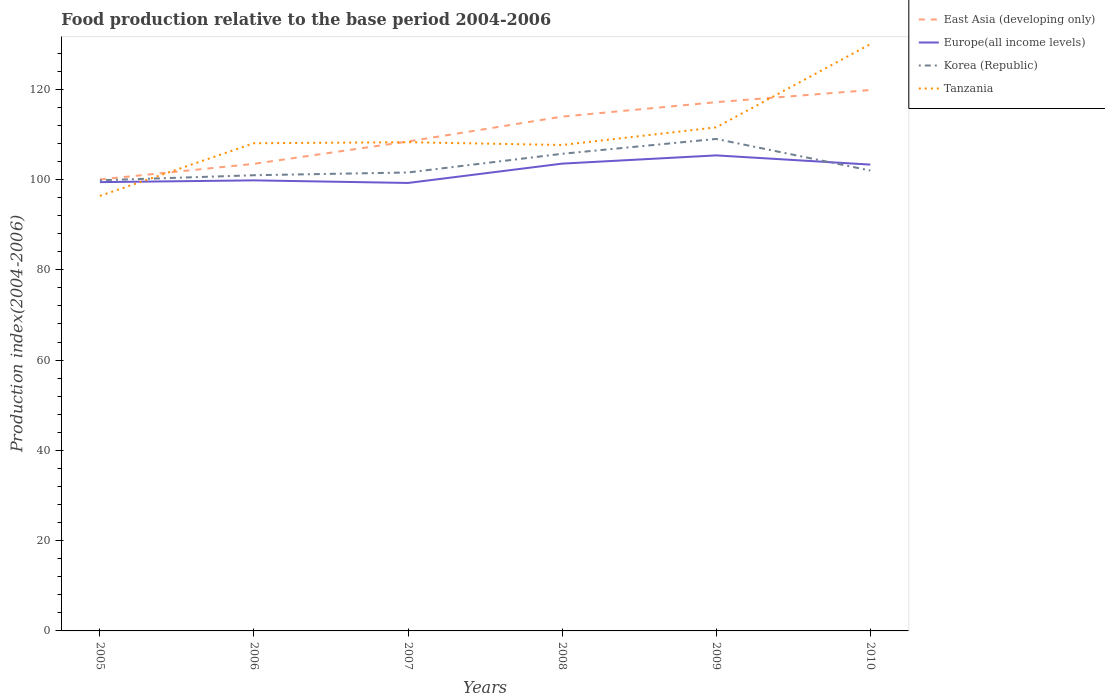Is the number of lines equal to the number of legend labels?
Offer a very short reply. Yes. Across all years, what is the maximum food production index in Tanzania?
Ensure brevity in your answer.  96.39. What is the total food production index in East Asia (developing only) in the graph?
Ensure brevity in your answer.  -19.81. What is the difference between the highest and the second highest food production index in East Asia (developing only)?
Your response must be concise. 19.81. How many lines are there?
Give a very brief answer. 4. How many years are there in the graph?
Your response must be concise. 6. What is the difference between two consecutive major ticks on the Y-axis?
Your answer should be very brief. 20. Does the graph contain grids?
Make the answer very short. No. How many legend labels are there?
Offer a terse response. 4. How are the legend labels stacked?
Your response must be concise. Vertical. What is the title of the graph?
Ensure brevity in your answer.  Food production relative to the base period 2004-2006. What is the label or title of the X-axis?
Your response must be concise. Years. What is the label or title of the Y-axis?
Your response must be concise. Production index(2004-2006). What is the Production index(2004-2006) in East Asia (developing only) in 2005?
Offer a very short reply. 100.03. What is the Production index(2004-2006) of Europe(all income levels) in 2005?
Your answer should be compact. 99.43. What is the Production index(2004-2006) in Korea (Republic) in 2005?
Your response must be concise. 99.84. What is the Production index(2004-2006) in Tanzania in 2005?
Keep it short and to the point. 96.39. What is the Production index(2004-2006) in East Asia (developing only) in 2006?
Ensure brevity in your answer.  103.49. What is the Production index(2004-2006) in Europe(all income levels) in 2006?
Your answer should be very brief. 99.82. What is the Production index(2004-2006) in Korea (Republic) in 2006?
Your response must be concise. 100.96. What is the Production index(2004-2006) of Tanzania in 2006?
Ensure brevity in your answer.  108.05. What is the Production index(2004-2006) of East Asia (developing only) in 2007?
Keep it short and to the point. 108.44. What is the Production index(2004-2006) in Europe(all income levels) in 2007?
Make the answer very short. 99.25. What is the Production index(2004-2006) in Korea (Republic) in 2007?
Keep it short and to the point. 101.57. What is the Production index(2004-2006) in Tanzania in 2007?
Ensure brevity in your answer.  108.28. What is the Production index(2004-2006) of East Asia (developing only) in 2008?
Your answer should be very brief. 113.95. What is the Production index(2004-2006) in Europe(all income levels) in 2008?
Your answer should be very brief. 103.53. What is the Production index(2004-2006) in Korea (Republic) in 2008?
Offer a very short reply. 105.71. What is the Production index(2004-2006) in Tanzania in 2008?
Your answer should be compact. 107.66. What is the Production index(2004-2006) in East Asia (developing only) in 2009?
Offer a very short reply. 117.15. What is the Production index(2004-2006) of Europe(all income levels) in 2009?
Offer a terse response. 105.36. What is the Production index(2004-2006) in Korea (Republic) in 2009?
Your response must be concise. 109. What is the Production index(2004-2006) of Tanzania in 2009?
Provide a short and direct response. 111.57. What is the Production index(2004-2006) of East Asia (developing only) in 2010?
Provide a succinct answer. 119.84. What is the Production index(2004-2006) in Europe(all income levels) in 2010?
Provide a succinct answer. 103.31. What is the Production index(2004-2006) in Korea (Republic) in 2010?
Ensure brevity in your answer.  102. What is the Production index(2004-2006) in Tanzania in 2010?
Keep it short and to the point. 130. Across all years, what is the maximum Production index(2004-2006) of East Asia (developing only)?
Offer a very short reply. 119.84. Across all years, what is the maximum Production index(2004-2006) in Europe(all income levels)?
Provide a succinct answer. 105.36. Across all years, what is the maximum Production index(2004-2006) in Korea (Republic)?
Ensure brevity in your answer.  109. Across all years, what is the maximum Production index(2004-2006) in Tanzania?
Provide a short and direct response. 130. Across all years, what is the minimum Production index(2004-2006) of East Asia (developing only)?
Provide a short and direct response. 100.03. Across all years, what is the minimum Production index(2004-2006) in Europe(all income levels)?
Your response must be concise. 99.25. Across all years, what is the minimum Production index(2004-2006) of Korea (Republic)?
Provide a short and direct response. 99.84. Across all years, what is the minimum Production index(2004-2006) of Tanzania?
Your response must be concise. 96.39. What is the total Production index(2004-2006) in East Asia (developing only) in the graph?
Give a very brief answer. 662.88. What is the total Production index(2004-2006) in Europe(all income levels) in the graph?
Your answer should be very brief. 610.71. What is the total Production index(2004-2006) of Korea (Republic) in the graph?
Offer a very short reply. 619.08. What is the total Production index(2004-2006) in Tanzania in the graph?
Offer a terse response. 661.95. What is the difference between the Production index(2004-2006) in East Asia (developing only) in 2005 and that in 2006?
Provide a succinct answer. -3.46. What is the difference between the Production index(2004-2006) in Europe(all income levels) in 2005 and that in 2006?
Offer a terse response. -0.39. What is the difference between the Production index(2004-2006) of Korea (Republic) in 2005 and that in 2006?
Provide a short and direct response. -1.12. What is the difference between the Production index(2004-2006) of Tanzania in 2005 and that in 2006?
Provide a short and direct response. -11.66. What is the difference between the Production index(2004-2006) in East Asia (developing only) in 2005 and that in 2007?
Ensure brevity in your answer.  -8.41. What is the difference between the Production index(2004-2006) of Europe(all income levels) in 2005 and that in 2007?
Provide a short and direct response. 0.19. What is the difference between the Production index(2004-2006) in Korea (Republic) in 2005 and that in 2007?
Provide a short and direct response. -1.73. What is the difference between the Production index(2004-2006) in Tanzania in 2005 and that in 2007?
Offer a terse response. -11.89. What is the difference between the Production index(2004-2006) in East Asia (developing only) in 2005 and that in 2008?
Provide a short and direct response. -13.92. What is the difference between the Production index(2004-2006) in Europe(all income levels) in 2005 and that in 2008?
Offer a very short reply. -4.1. What is the difference between the Production index(2004-2006) of Korea (Republic) in 2005 and that in 2008?
Offer a terse response. -5.87. What is the difference between the Production index(2004-2006) in Tanzania in 2005 and that in 2008?
Your answer should be very brief. -11.27. What is the difference between the Production index(2004-2006) in East Asia (developing only) in 2005 and that in 2009?
Ensure brevity in your answer.  -17.12. What is the difference between the Production index(2004-2006) in Europe(all income levels) in 2005 and that in 2009?
Your answer should be very brief. -5.92. What is the difference between the Production index(2004-2006) in Korea (Republic) in 2005 and that in 2009?
Offer a terse response. -9.16. What is the difference between the Production index(2004-2006) of Tanzania in 2005 and that in 2009?
Offer a very short reply. -15.18. What is the difference between the Production index(2004-2006) of East Asia (developing only) in 2005 and that in 2010?
Keep it short and to the point. -19.81. What is the difference between the Production index(2004-2006) of Europe(all income levels) in 2005 and that in 2010?
Give a very brief answer. -3.88. What is the difference between the Production index(2004-2006) in Korea (Republic) in 2005 and that in 2010?
Offer a very short reply. -2.16. What is the difference between the Production index(2004-2006) of Tanzania in 2005 and that in 2010?
Provide a succinct answer. -33.61. What is the difference between the Production index(2004-2006) in East Asia (developing only) in 2006 and that in 2007?
Give a very brief answer. -4.95. What is the difference between the Production index(2004-2006) in Europe(all income levels) in 2006 and that in 2007?
Make the answer very short. 0.57. What is the difference between the Production index(2004-2006) of Korea (Republic) in 2006 and that in 2007?
Keep it short and to the point. -0.61. What is the difference between the Production index(2004-2006) in Tanzania in 2006 and that in 2007?
Give a very brief answer. -0.23. What is the difference between the Production index(2004-2006) of East Asia (developing only) in 2006 and that in 2008?
Your answer should be compact. -10.46. What is the difference between the Production index(2004-2006) of Europe(all income levels) in 2006 and that in 2008?
Provide a short and direct response. -3.71. What is the difference between the Production index(2004-2006) of Korea (Republic) in 2006 and that in 2008?
Your answer should be compact. -4.75. What is the difference between the Production index(2004-2006) of Tanzania in 2006 and that in 2008?
Give a very brief answer. 0.39. What is the difference between the Production index(2004-2006) of East Asia (developing only) in 2006 and that in 2009?
Your answer should be compact. -13.66. What is the difference between the Production index(2004-2006) in Europe(all income levels) in 2006 and that in 2009?
Offer a very short reply. -5.53. What is the difference between the Production index(2004-2006) in Korea (Republic) in 2006 and that in 2009?
Ensure brevity in your answer.  -8.04. What is the difference between the Production index(2004-2006) of Tanzania in 2006 and that in 2009?
Your response must be concise. -3.52. What is the difference between the Production index(2004-2006) of East Asia (developing only) in 2006 and that in 2010?
Your response must be concise. -16.35. What is the difference between the Production index(2004-2006) in Europe(all income levels) in 2006 and that in 2010?
Your answer should be compact. -3.49. What is the difference between the Production index(2004-2006) of Korea (Republic) in 2006 and that in 2010?
Provide a short and direct response. -1.04. What is the difference between the Production index(2004-2006) of Tanzania in 2006 and that in 2010?
Offer a terse response. -21.95. What is the difference between the Production index(2004-2006) of East Asia (developing only) in 2007 and that in 2008?
Your response must be concise. -5.51. What is the difference between the Production index(2004-2006) of Europe(all income levels) in 2007 and that in 2008?
Provide a short and direct response. -4.28. What is the difference between the Production index(2004-2006) of Korea (Republic) in 2007 and that in 2008?
Offer a very short reply. -4.14. What is the difference between the Production index(2004-2006) in Tanzania in 2007 and that in 2008?
Offer a terse response. 0.62. What is the difference between the Production index(2004-2006) of East Asia (developing only) in 2007 and that in 2009?
Provide a succinct answer. -8.71. What is the difference between the Production index(2004-2006) in Europe(all income levels) in 2007 and that in 2009?
Offer a terse response. -6.11. What is the difference between the Production index(2004-2006) in Korea (Republic) in 2007 and that in 2009?
Your response must be concise. -7.43. What is the difference between the Production index(2004-2006) in Tanzania in 2007 and that in 2009?
Make the answer very short. -3.29. What is the difference between the Production index(2004-2006) of East Asia (developing only) in 2007 and that in 2010?
Provide a succinct answer. -11.4. What is the difference between the Production index(2004-2006) in Europe(all income levels) in 2007 and that in 2010?
Provide a short and direct response. -4.06. What is the difference between the Production index(2004-2006) in Korea (Republic) in 2007 and that in 2010?
Provide a succinct answer. -0.43. What is the difference between the Production index(2004-2006) in Tanzania in 2007 and that in 2010?
Your answer should be compact. -21.72. What is the difference between the Production index(2004-2006) of East Asia (developing only) in 2008 and that in 2009?
Your answer should be compact. -3.2. What is the difference between the Production index(2004-2006) of Europe(all income levels) in 2008 and that in 2009?
Provide a succinct answer. -1.82. What is the difference between the Production index(2004-2006) in Korea (Republic) in 2008 and that in 2009?
Your answer should be compact. -3.29. What is the difference between the Production index(2004-2006) of Tanzania in 2008 and that in 2009?
Your answer should be very brief. -3.91. What is the difference between the Production index(2004-2006) of East Asia (developing only) in 2008 and that in 2010?
Your response must be concise. -5.89. What is the difference between the Production index(2004-2006) of Europe(all income levels) in 2008 and that in 2010?
Provide a short and direct response. 0.22. What is the difference between the Production index(2004-2006) of Korea (Republic) in 2008 and that in 2010?
Your answer should be very brief. 3.71. What is the difference between the Production index(2004-2006) in Tanzania in 2008 and that in 2010?
Give a very brief answer. -22.34. What is the difference between the Production index(2004-2006) in East Asia (developing only) in 2009 and that in 2010?
Your answer should be very brief. -2.69. What is the difference between the Production index(2004-2006) in Europe(all income levels) in 2009 and that in 2010?
Offer a very short reply. 2.04. What is the difference between the Production index(2004-2006) of Tanzania in 2009 and that in 2010?
Give a very brief answer. -18.43. What is the difference between the Production index(2004-2006) of East Asia (developing only) in 2005 and the Production index(2004-2006) of Europe(all income levels) in 2006?
Offer a terse response. 0.2. What is the difference between the Production index(2004-2006) of East Asia (developing only) in 2005 and the Production index(2004-2006) of Korea (Republic) in 2006?
Make the answer very short. -0.93. What is the difference between the Production index(2004-2006) in East Asia (developing only) in 2005 and the Production index(2004-2006) in Tanzania in 2006?
Provide a succinct answer. -8.02. What is the difference between the Production index(2004-2006) of Europe(all income levels) in 2005 and the Production index(2004-2006) of Korea (Republic) in 2006?
Keep it short and to the point. -1.53. What is the difference between the Production index(2004-2006) in Europe(all income levels) in 2005 and the Production index(2004-2006) in Tanzania in 2006?
Make the answer very short. -8.62. What is the difference between the Production index(2004-2006) in Korea (Republic) in 2005 and the Production index(2004-2006) in Tanzania in 2006?
Keep it short and to the point. -8.21. What is the difference between the Production index(2004-2006) in East Asia (developing only) in 2005 and the Production index(2004-2006) in Europe(all income levels) in 2007?
Your response must be concise. 0.78. What is the difference between the Production index(2004-2006) of East Asia (developing only) in 2005 and the Production index(2004-2006) of Korea (Republic) in 2007?
Your answer should be compact. -1.54. What is the difference between the Production index(2004-2006) in East Asia (developing only) in 2005 and the Production index(2004-2006) in Tanzania in 2007?
Provide a succinct answer. -8.25. What is the difference between the Production index(2004-2006) in Europe(all income levels) in 2005 and the Production index(2004-2006) in Korea (Republic) in 2007?
Offer a very short reply. -2.14. What is the difference between the Production index(2004-2006) of Europe(all income levels) in 2005 and the Production index(2004-2006) of Tanzania in 2007?
Ensure brevity in your answer.  -8.85. What is the difference between the Production index(2004-2006) of Korea (Republic) in 2005 and the Production index(2004-2006) of Tanzania in 2007?
Your answer should be very brief. -8.44. What is the difference between the Production index(2004-2006) of East Asia (developing only) in 2005 and the Production index(2004-2006) of Europe(all income levels) in 2008?
Provide a short and direct response. -3.51. What is the difference between the Production index(2004-2006) of East Asia (developing only) in 2005 and the Production index(2004-2006) of Korea (Republic) in 2008?
Your response must be concise. -5.68. What is the difference between the Production index(2004-2006) in East Asia (developing only) in 2005 and the Production index(2004-2006) in Tanzania in 2008?
Your answer should be very brief. -7.63. What is the difference between the Production index(2004-2006) in Europe(all income levels) in 2005 and the Production index(2004-2006) in Korea (Republic) in 2008?
Your answer should be compact. -6.28. What is the difference between the Production index(2004-2006) in Europe(all income levels) in 2005 and the Production index(2004-2006) in Tanzania in 2008?
Provide a succinct answer. -8.23. What is the difference between the Production index(2004-2006) in Korea (Republic) in 2005 and the Production index(2004-2006) in Tanzania in 2008?
Keep it short and to the point. -7.82. What is the difference between the Production index(2004-2006) in East Asia (developing only) in 2005 and the Production index(2004-2006) in Europe(all income levels) in 2009?
Provide a succinct answer. -5.33. What is the difference between the Production index(2004-2006) in East Asia (developing only) in 2005 and the Production index(2004-2006) in Korea (Republic) in 2009?
Offer a very short reply. -8.97. What is the difference between the Production index(2004-2006) of East Asia (developing only) in 2005 and the Production index(2004-2006) of Tanzania in 2009?
Your answer should be compact. -11.54. What is the difference between the Production index(2004-2006) of Europe(all income levels) in 2005 and the Production index(2004-2006) of Korea (Republic) in 2009?
Offer a very short reply. -9.57. What is the difference between the Production index(2004-2006) in Europe(all income levels) in 2005 and the Production index(2004-2006) in Tanzania in 2009?
Your answer should be very brief. -12.14. What is the difference between the Production index(2004-2006) in Korea (Republic) in 2005 and the Production index(2004-2006) in Tanzania in 2009?
Ensure brevity in your answer.  -11.73. What is the difference between the Production index(2004-2006) in East Asia (developing only) in 2005 and the Production index(2004-2006) in Europe(all income levels) in 2010?
Keep it short and to the point. -3.29. What is the difference between the Production index(2004-2006) in East Asia (developing only) in 2005 and the Production index(2004-2006) in Korea (Republic) in 2010?
Give a very brief answer. -1.97. What is the difference between the Production index(2004-2006) of East Asia (developing only) in 2005 and the Production index(2004-2006) of Tanzania in 2010?
Your response must be concise. -29.97. What is the difference between the Production index(2004-2006) in Europe(all income levels) in 2005 and the Production index(2004-2006) in Korea (Republic) in 2010?
Your answer should be very brief. -2.57. What is the difference between the Production index(2004-2006) of Europe(all income levels) in 2005 and the Production index(2004-2006) of Tanzania in 2010?
Offer a very short reply. -30.57. What is the difference between the Production index(2004-2006) of Korea (Republic) in 2005 and the Production index(2004-2006) of Tanzania in 2010?
Offer a very short reply. -30.16. What is the difference between the Production index(2004-2006) of East Asia (developing only) in 2006 and the Production index(2004-2006) of Europe(all income levels) in 2007?
Keep it short and to the point. 4.24. What is the difference between the Production index(2004-2006) in East Asia (developing only) in 2006 and the Production index(2004-2006) in Korea (Republic) in 2007?
Your response must be concise. 1.92. What is the difference between the Production index(2004-2006) of East Asia (developing only) in 2006 and the Production index(2004-2006) of Tanzania in 2007?
Your answer should be compact. -4.79. What is the difference between the Production index(2004-2006) in Europe(all income levels) in 2006 and the Production index(2004-2006) in Korea (Republic) in 2007?
Your answer should be very brief. -1.75. What is the difference between the Production index(2004-2006) of Europe(all income levels) in 2006 and the Production index(2004-2006) of Tanzania in 2007?
Give a very brief answer. -8.46. What is the difference between the Production index(2004-2006) of Korea (Republic) in 2006 and the Production index(2004-2006) of Tanzania in 2007?
Keep it short and to the point. -7.32. What is the difference between the Production index(2004-2006) in East Asia (developing only) in 2006 and the Production index(2004-2006) in Europe(all income levels) in 2008?
Give a very brief answer. -0.05. What is the difference between the Production index(2004-2006) of East Asia (developing only) in 2006 and the Production index(2004-2006) of Korea (Republic) in 2008?
Provide a short and direct response. -2.22. What is the difference between the Production index(2004-2006) of East Asia (developing only) in 2006 and the Production index(2004-2006) of Tanzania in 2008?
Provide a short and direct response. -4.17. What is the difference between the Production index(2004-2006) of Europe(all income levels) in 2006 and the Production index(2004-2006) of Korea (Republic) in 2008?
Offer a very short reply. -5.89. What is the difference between the Production index(2004-2006) in Europe(all income levels) in 2006 and the Production index(2004-2006) in Tanzania in 2008?
Provide a short and direct response. -7.84. What is the difference between the Production index(2004-2006) of Korea (Republic) in 2006 and the Production index(2004-2006) of Tanzania in 2008?
Your answer should be very brief. -6.7. What is the difference between the Production index(2004-2006) in East Asia (developing only) in 2006 and the Production index(2004-2006) in Europe(all income levels) in 2009?
Your response must be concise. -1.87. What is the difference between the Production index(2004-2006) of East Asia (developing only) in 2006 and the Production index(2004-2006) of Korea (Republic) in 2009?
Ensure brevity in your answer.  -5.51. What is the difference between the Production index(2004-2006) in East Asia (developing only) in 2006 and the Production index(2004-2006) in Tanzania in 2009?
Provide a short and direct response. -8.08. What is the difference between the Production index(2004-2006) of Europe(all income levels) in 2006 and the Production index(2004-2006) of Korea (Republic) in 2009?
Make the answer very short. -9.18. What is the difference between the Production index(2004-2006) of Europe(all income levels) in 2006 and the Production index(2004-2006) of Tanzania in 2009?
Offer a very short reply. -11.75. What is the difference between the Production index(2004-2006) in Korea (Republic) in 2006 and the Production index(2004-2006) in Tanzania in 2009?
Provide a succinct answer. -10.61. What is the difference between the Production index(2004-2006) in East Asia (developing only) in 2006 and the Production index(2004-2006) in Europe(all income levels) in 2010?
Ensure brevity in your answer.  0.17. What is the difference between the Production index(2004-2006) in East Asia (developing only) in 2006 and the Production index(2004-2006) in Korea (Republic) in 2010?
Offer a terse response. 1.49. What is the difference between the Production index(2004-2006) of East Asia (developing only) in 2006 and the Production index(2004-2006) of Tanzania in 2010?
Offer a very short reply. -26.51. What is the difference between the Production index(2004-2006) of Europe(all income levels) in 2006 and the Production index(2004-2006) of Korea (Republic) in 2010?
Offer a terse response. -2.18. What is the difference between the Production index(2004-2006) in Europe(all income levels) in 2006 and the Production index(2004-2006) in Tanzania in 2010?
Make the answer very short. -30.18. What is the difference between the Production index(2004-2006) of Korea (Republic) in 2006 and the Production index(2004-2006) of Tanzania in 2010?
Your answer should be compact. -29.04. What is the difference between the Production index(2004-2006) of East Asia (developing only) in 2007 and the Production index(2004-2006) of Europe(all income levels) in 2008?
Make the answer very short. 4.91. What is the difference between the Production index(2004-2006) of East Asia (developing only) in 2007 and the Production index(2004-2006) of Korea (Republic) in 2008?
Offer a terse response. 2.73. What is the difference between the Production index(2004-2006) in East Asia (developing only) in 2007 and the Production index(2004-2006) in Tanzania in 2008?
Your answer should be compact. 0.78. What is the difference between the Production index(2004-2006) in Europe(all income levels) in 2007 and the Production index(2004-2006) in Korea (Republic) in 2008?
Ensure brevity in your answer.  -6.46. What is the difference between the Production index(2004-2006) in Europe(all income levels) in 2007 and the Production index(2004-2006) in Tanzania in 2008?
Provide a short and direct response. -8.41. What is the difference between the Production index(2004-2006) in Korea (Republic) in 2007 and the Production index(2004-2006) in Tanzania in 2008?
Your answer should be compact. -6.09. What is the difference between the Production index(2004-2006) of East Asia (developing only) in 2007 and the Production index(2004-2006) of Europe(all income levels) in 2009?
Make the answer very short. 3.08. What is the difference between the Production index(2004-2006) of East Asia (developing only) in 2007 and the Production index(2004-2006) of Korea (Republic) in 2009?
Keep it short and to the point. -0.56. What is the difference between the Production index(2004-2006) in East Asia (developing only) in 2007 and the Production index(2004-2006) in Tanzania in 2009?
Keep it short and to the point. -3.13. What is the difference between the Production index(2004-2006) of Europe(all income levels) in 2007 and the Production index(2004-2006) of Korea (Republic) in 2009?
Your response must be concise. -9.75. What is the difference between the Production index(2004-2006) in Europe(all income levels) in 2007 and the Production index(2004-2006) in Tanzania in 2009?
Your answer should be very brief. -12.32. What is the difference between the Production index(2004-2006) of Korea (Republic) in 2007 and the Production index(2004-2006) of Tanzania in 2009?
Your answer should be compact. -10. What is the difference between the Production index(2004-2006) of East Asia (developing only) in 2007 and the Production index(2004-2006) of Europe(all income levels) in 2010?
Make the answer very short. 5.13. What is the difference between the Production index(2004-2006) of East Asia (developing only) in 2007 and the Production index(2004-2006) of Korea (Republic) in 2010?
Keep it short and to the point. 6.44. What is the difference between the Production index(2004-2006) of East Asia (developing only) in 2007 and the Production index(2004-2006) of Tanzania in 2010?
Make the answer very short. -21.56. What is the difference between the Production index(2004-2006) of Europe(all income levels) in 2007 and the Production index(2004-2006) of Korea (Republic) in 2010?
Keep it short and to the point. -2.75. What is the difference between the Production index(2004-2006) of Europe(all income levels) in 2007 and the Production index(2004-2006) of Tanzania in 2010?
Offer a very short reply. -30.75. What is the difference between the Production index(2004-2006) of Korea (Republic) in 2007 and the Production index(2004-2006) of Tanzania in 2010?
Provide a succinct answer. -28.43. What is the difference between the Production index(2004-2006) of East Asia (developing only) in 2008 and the Production index(2004-2006) of Europe(all income levels) in 2009?
Make the answer very short. 8.59. What is the difference between the Production index(2004-2006) in East Asia (developing only) in 2008 and the Production index(2004-2006) in Korea (Republic) in 2009?
Make the answer very short. 4.95. What is the difference between the Production index(2004-2006) of East Asia (developing only) in 2008 and the Production index(2004-2006) of Tanzania in 2009?
Provide a short and direct response. 2.38. What is the difference between the Production index(2004-2006) of Europe(all income levels) in 2008 and the Production index(2004-2006) of Korea (Republic) in 2009?
Your response must be concise. -5.47. What is the difference between the Production index(2004-2006) of Europe(all income levels) in 2008 and the Production index(2004-2006) of Tanzania in 2009?
Make the answer very short. -8.04. What is the difference between the Production index(2004-2006) of Korea (Republic) in 2008 and the Production index(2004-2006) of Tanzania in 2009?
Ensure brevity in your answer.  -5.86. What is the difference between the Production index(2004-2006) of East Asia (developing only) in 2008 and the Production index(2004-2006) of Europe(all income levels) in 2010?
Make the answer very short. 10.63. What is the difference between the Production index(2004-2006) in East Asia (developing only) in 2008 and the Production index(2004-2006) in Korea (Republic) in 2010?
Provide a short and direct response. 11.95. What is the difference between the Production index(2004-2006) of East Asia (developing only) in 2008 and the Production index(2004-2006) of Tanzania in 2010?
Offer a terse response. -16.05. What is the difference between the Production index(2004-2006) of Europe(all income levels) in 2008 and the Production index(2004-2006) of Korea (Republic) in 2010?
Your response must be concise. 1.53. What is the difference between the Production index(2004-2006) of Europe(all income levels) in 2008 and the Production index(2004-2006) of Tanzania in 2010?
Give a very brief answer. -26.47. What is the difference between the Production index(2004-2006) of Korea (Republic) in 2008 and the Production index(2004-2006) of Tanzania in 2010?
Keep it short and to the point. -24.29. What is the difference between the Production index(2004-2006) in East Asia (developing only) in 2009 and the Production index(2004-2006) in Europe(all income levels) in 2010?
Keep it short and to the point. 13.84. What is the difference between the Production index(2004-2006) of East Asia (developing only) in 2009 and the Production index(2004-2006) of Korea (Republic) in 2010?
Ensure brevity in your answer.  15.15. What is the difference between the Production index(2004-2006) of East Asia (developing only) in 2009 and the Production index(2004-2006) of Tanzania in 2010?
Offer a terse response. -12.85. What is the difference between the Production index(2004-2006) of Europe(all income levels) in 2009 and the Production index(2004-2006) of Korea (Republic) in 2010?
Keep it short and to the point. 3.36. What is the difference between the Production index(2004-2006) of Europe(all income levels) in 2009 and the Production index(2004-2006) of Tanzania in 2010?
Give a very brief answer. -24.64. What is the average Production index(2004-2006) in East Asia (developing only) per year?
Keep it short and to the point. 110.48. What is the average Production index(2004-2006) of Europe(all income levels) per year?
Provide a succinct answer. 101.78. What is the average Production index(2004-2006) in Korea (Republic) per year?
Offer a terse response. 103.18. What is the average Production index(2004-2006) in Tanzania per year?
Offer a very short reply. 110.33. In the year 2005, what is the difference between the Production index(2004-2006) of East Asia (developing only) and Production index(2004-2006) of Europe(all income levels)?
Offer a terse response. 0.59. In the year 2005, what is the difference between the Production index(2004-2006) of East Asia (developing only) and Production index(2004-2006) of Korea (Republic)?
Your answer should be very brief. 0.19. In the year 2005, what is the difference between the Production index(2004-2006) of East Asia (developing only) and Production index(2004-2006) of Tanzania?
Offer a very short reply. 3.64. In the year 2005, what is the difference between the Production index(2004-2006) in Europe(all income levels) and Production index(2004-2006) in Korea (Republic)?
Provide a short and direct response. -0.41. In the year 2005, what is the difference between the Production index(2004-2006) of Europe(all income levels) and Production index(2004-2006) of Tanzania?
Your answer should be very brief. 3.04. In the year 2005, what is the difference between the Production index(2004-2006) of Korea (Republic) and Production index(2004-2006) of Tanzania?
Your answer should be very brief. 3.45. In the year 2006, what is the difference between the Production index(2004-2006) in East Asia (developing only) and Production index(2004-2006) in Europe(all income levels)?
Keep it short and to the point. 3.66. In the year 2006, what is the difference between the Production index(2004-2006) in East Asia (developing only) and Production index(2004-2006) in Korea (Republic)?
Provide a succinct answer. 2.53. In the year 2006, what is the difference between the Production index(2004-2006) in East Asia (developing only) and Production index(2004-2006) in Tanzania?
Provide a short and direct response. -4.56. In the year 2006, what is the difference between the Production index(2004-2006) in Europe(all income levels) and Production index(2004-2006) in Korea (Republic)?
Keep it short and to the point. -1.14. In the year 2006, what is the difference between the Production index(2004-2006) in Europe(all income levels) and Production index(2004-2006) in Tanzania?
Offer a very short reply. -8.23. In the year 2006, what is the difference between the Production index(2004-2006) in Korea (Republic) and Production index(2004-2006) in Tanzania?
Your answer should be compact. -7.09. In the year 2007, what is the difference between the Production index(2004-2006) in East Asia (developing only) and Production index(2004-2006) in Europe(all income levels)?
Ensure brevity in your answer.  9.19. In the year 2007, what is the difference between the Production index(2004-2006) in East Asia (developing only) and Production index(2004-2006) in Korea (Republic)?
Make the answer very short. 6.87. In the year 2007, what is the difference between the Production index(2004-2006) of East Asia (developing only) and Production index(2004-2006) of Tanzania?
Offer a terse response. 0.16. In the year 2007, what is the difference between the Production index(2004-2006) of Europe(all income levels) and Production index(2004-2006) of Korea (Republic)?
Give a very brief answer. -2.32. In the year 2007, what is the difference between the Production index(2004-2006) in Europe(all income levels) and Production index(2004-2006) in Tanzania?
Offer a very short reply. -9.03. In the year 2007, what is the difference between the Production index(2004-2006) in Korea (Republic) and Production index(2004-2006) in Tanzania?
Keep it short and to the point. -6.71. In the year 2008, what is the difference between the Production index(2004-2006) in East Asia (developing only) and Production index(2004-2006) in Europe(all income levels)?
Make the answer very short. 10.42. In the year 2008, what is the difference between the Production index(2004-2006) of East Asia (developing only) and Production index(2004-2006) of Korea (Republic)?
Offer a very short reply. 8.24. In the year 2008, what is the difference between the Production index(2004-2006) of East Asia (developing only) and Production index(2004-2006) of Tanzania?
Your answer should be compact. 6.29. In the year 2008, what is the difference between the Production index(2004-2006) of Europe(all income levels) and Production index(2004-2006) of Korea (Republic)?
Offer a terse response. -2.18. In the year 2008, what is the difference between the Production index(2004-2006) of Europe(all income levels) and Production index(2004-2006) of Tanzania?
Your answer should be very brief. -4.13. In the year 2008, what is the difference between the Production index(2004-2006) in Korea (Republic) and Production index(2004-2006) in Tanzania?
Offer a terse response. -1.95. In the year 2009, what is the difference between the Production index(2004-2006) in East Asia (developing only) and Production index(2004-2006) in Europe(all income levels)?
Provide a short and direct response. 11.79. In the year 2009, what is the difference between the Production index(2004-2006) of East Asia (developing only) and Production index(2004-2006) of Korea (Republic)?
Offer a very short reply. 8.15. In the year 2009, what is the difference between the Production index(2004-2006) in East Asia (developing only) and Production index(2004-2006) in Tanzania?
Give a very brief answer. 5.58. In the year 2009, what is the difference between the Production index(2004-2006) of Europe(all income levels) and Production index(2004-2006) of Korea (Republic)?
Offer a terse response. -3.64. In the year 2009, what is the difference between the Production index(2004-2006) of Europe(all income levels) and Production index(2004-2006) of Tanzania?
Provide a succinct answer. -6.21. In the year 2009, what is the difference between the Production index(2004-2006) in Korea (Republic) and Production index(2004-2006) in Tanzania?
Ensure brevity in your answer.  -2.57. In the year 2010, what is the difference between the Production index(2004-2006) in East Asia (developing only) and Production index(2004-2006) in Europe(all income levels)?
Offer a very short reply. 16.52. In the year 2010, what is the difference between the Production index(2004-2006) of East Asia (developing only) and Production index(2004-2006) of Korea (Republic)?
Offer a terse response. 17.84. In the year 2010, what is the difference between the Production index(2004-2006) of East Asia (developing only) and Production index(2004-2006) of Tanzania?
Make the answer very short. -10.16. In the year 2010, what is the difference between the Production index(2004-2006) of Europe(all income levels) and Production index(2004-2006) of Korea (Republic)?
Give a very brief answer. 1.31. In the year 2010, what is the difference between the Production index(2004-2006) of Europe(all income levels) and Production index(2004-2006) of Tanzania?
Offer a terse response. -26.69. What is the ratio of the Production index(2004-2006) in East Asia (developing only) in 2005 to that in 2006?
Provide a succinct answer. 0.97. What is the ratio of the Production index(2004-2006) in Europe(all income levels) in 2005 to that in 2006?
Your answer should be very brief. 1. What is the ratio of the Production index(2004-2006) of Korea (Republic) in 2005 to that in 2006?
Offer a terse response. 0.99. What is the ratio of the Production index(2004-2006) in Tanzania in 2005 to that in 2006?
Keep it short and to the point. 0.89. What is the ratio of the Production index(2004-2006) of East Asia (developing only) in 2005 to that in 2007?
Provide a succinct answer. 0.92. What is the ratio of the Production index(2004-2006) in Europe(all income levels) in 2005 to that in 2007?
Your response must be concise. 1. What is the ratio of the Production index(2004-2006) in Korea (Republic) in 2005 to that in 2007?
Your answer should be compact. 0.98. What is the ratio of the Production index(2004-2006) of Tanzania in 2005 to that in 2007?
Provide a short and direct response. 0.89. What is the ratio of the Production index(2004-2006) of East Asia (developing only) in 2005 to that in 2008?
Ensure brevity in your answer.  0.88. What is the ratio of the Production index(2004-2006) of Europe(all income levels) in 2005 to that in 2008?
Offer a terse response. 0.96. What is the ratio of the Production index(2004-2006) of Korea (Republic) in 2005 to that in 2008?
Ensure brevity in your answer.  0.94. What is the ratio of the Production index(2004-2006) of Tanzania in 2005 to that in 2008?
Make the answer very short. 0.9. What is the ratio of the Production index(2004-2006) of East Asia (developing only) in 2005 to that in 2009?
Provide a succinct answer. 0.85. What is the ratio of the Production index(2004-2006) of Europe(all income levels) in 2005 to that in 2009?
Ensure brevity in your answer.  0.94. What is the ratio of the Production index(2004-2006) of Korea (Republic) in 2005 to that in 2009?
Provide a short and direct response. 0.92. What is the ratio of the Production index(2004-2006) of Tanzania in 2005 to that in 2009?
Make the answer very short. 0.86. What is the ratio of the Production index(2004-2006) in East Asia (developing only) in 2005 to that in 2010?
Make the answer very short. 0.83. What is the ratio of the Production index(2004-2006) of Europe(all income levels) in 2005 to that in 2010?
Give a very brief answer. 0.96. What is the ratio of the Production index(2004-2006) in Korea (Republic) in 2005 to that in 2010?
Provide a succinct answer. 0.98. What is the ratio of the Production index(2004-2006) of Tanzania in 2005 to that in 2010?
Keep it short and to the point. 0.74. What is the ratio of the Production index(2004-2006) in East Asia (developing only) in 2006 to that in 2007?
Ensure brevity in your answer.  0.95. What is the ratio of the Production index(2004-2006) in Europe(all income levels) in 2006 to that in 2007?
Offer a terse response. 1.01. What is the ratio of the Production index(2004-2006) in Tanzania in 2006 to that in 2007?
Ensure brevity in your answer.  1. What is the ratio of the Production index(2004-2006) in East Asia (developing only) in 2006 to that in 2008?
Ensure brevity in your answer.  0.91. What is the ratio of the Production index(2004-2006) of Europe(all income levels) in 2006 to that in 2008?
Your response must be concise. 0.96. What is the ratio of the Production index(2004-2006) of Korea (Republic) in 2006 to that in 2008?
Offer a very short reply. 0.96. What is the ratio of the Production index(2004-2006) in Tanzania in 2006 to that in 2008?
Your response must be concise. 1. What is the ratio of the Production index(2004-2006) in East Asia (developing only) in 2006 to that in 2009?
Provide a succinct answer. 0.88. What is the ratio of the Production index(2004-2006) of Europe(all income levels) in 2006 to that in 2009?
Offer a very short reply. 0.95. What is the ratio of the Production index(2004-2006) in Korea (Republic) in 2006 to that in 2009?
Provide a short and direct response. 0.93. What is the ratio of the Production index(2004-2006) of Tanzania in 2006 to that in 2009?
Give a very brief answer. 0.97. What is the ratio of the Production index(2004-2006) of East Asia (developing only) in 2006 to that in 2010?
Your answer should be compact. 0.86. What is the ratio of the Production index(2004-2006) in Europe(all income levels) in 2006 to that in 2010?
Your response must be concise. 0.97. What is the ratio of the Production index(2004-2006) in Korea (Republic) in 2006 to that in 2010?
Your answer should be very brief. 0.99. What is the ratio of the Production index(2004-2006) of Tanzania in 2006 to that in 2010?
Provide a succinct answer. 0.83. What is the ratio of the Production index(2004-2006) in East Asia (developing only) in 2007 to that in 2008?
Offer a terse response. 0.95. What is the ratio of the Production index(2004-2006) in Europe(all income levels) in 2007 to that in 2008?
Your response must be concise. 0.96. What is the ratio of the Production index(2004-2006) of Korea (Republic) in 2007 to that in 2008?
Give a very brief answer. 0.96. What is the ratio of the Production index(2004-2006) of Tanzania in 2007 to that in 2008?
Make the answer very short. 1.01. What is the ratio of the Production index(2004-2006) of East Asia (developing only) in 2007 to that in 2009?
Give a very brief answer. 0.93. What is the ratio of the Production index(2004-2006) of Europe(all income levels) in 2007 to that in 2009?
Your response must be concise. 0.94. What is the ratio of the Production index(2004-2006) of Korea (Republic) in 2007 to that in 2009?
Make the answer very short. 0.93. What is the ratio of the Production index(2004-2006) of Tanzania in 2007 to that in 2009?
Make the answer very short. 0.97. What is the ratio of the Production index(2004-2006) in East Asia (developing only) in 2007 to that in 2010?
Offer a very short reply. 0.9. What is the ratio of the Production index(2004-2006) in Europe(all income levels) in 2007 to that in 2010?
Provide a short and direct response. 0.96. What is the ratio of the Production index(2004-2006) in Tanzania in 2007 to that in 2010?
Offer a terse response. 0.83. What is the ratio of the Production index(2004-2006) in East Asia (developing only) in 2008 to that in 2009?
Offer a very short reply. 0.97. What is the ratio of the Production index(2004-2006) in Europe(all income levels) in 2008 to that in 2009?
Give a very brief answer. 0.98. What is the ratio of the Production index(2004-2006) of Korea (Republic) in 2008 to that in 2009?
Keep it short and to the point. 0.97. What is the ratio of the Production index(2004-2006) of East Asia (developing only) in 2008 to that in 2010?
Your answer should be compact. 0.95. What is the ratio of the Production index(2004-2006) in Korea (Republic) in 2008 to that in 2010?
Provide a succinct answer. 1.04. What is the ratio of the Production index(2004-2006) of Tanzania in 2008 to that in 2010?
Provide a short and direct response. 0.83. What is the ratio of the Production index(2004-2006) of East Asia (developing only) in 2009 to that in 2010?
Provide a short and direct response. 0.98. What is the ratio of the Production index(2004-2006) of Europe(all income levels) in 2009 to that in 2010?
Your response must be concise. 1.02. What is the ratio of the Production index(2004-2006) in Korea (Republic) in 2009 to that in 2010?
Offer a terse response. 1.07. What is the ratio of the Production index(2004-2006) of Tanzania in 2009 to that in 2010?
Give a very brief answer. 0.86. What is the difference between the highest and the second highest Production index(2004-2006) in East Asia (developing only)?
Provide a succinct answer. 2.69. What is the difference between the highest and the second highest Production index(2004-2006) in Europe(all income levels)?
Offer a terse response. 1.82. What is the difference between the highest and the second highest Production index(2004-2006) of Korea (Republic)?
Make the answer very short. 3.29. What is the difference between the highest and the second highest Production index(2004-2006) of Tanzania?
Keep it short and to the point. 18.43. What is the difference between the highest and the lowest Production index(2004-2006) of East Asia (developing only)?
Provide a short and direct response. 19.81. What is the difference between the highest and the lowest Production index(2004-2006) in Europe(all income levels)?
Offer a very short reply. 6.11. What is the difference between the highest and the lowest Production index(2004-2006) in Korea (Republic)?
Your answer should be very brief. 9.16. What is the difference between the highest and the lowest Production index(2004-2006) in Tanzania?
Your response must be concise. 33.61. 